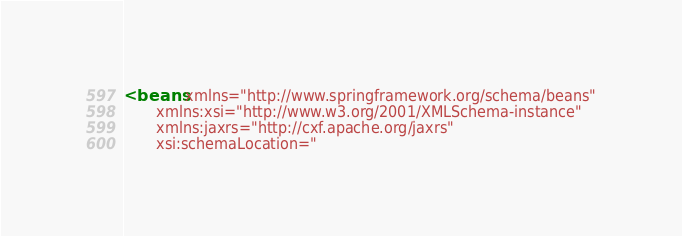Convert code to text. <code><loc_0><loc_0><loc_500><loc_500><_XML_><beans xmlns="http://www.springframework.org/schema/beans"
       xmlns:xsi="http://www.w3.org/2001/XMLSchema-instance"
       xmlns:jaxrs="http://cxf.apache.org/jaxrs"
       xsi:schemaLocation="</code> 